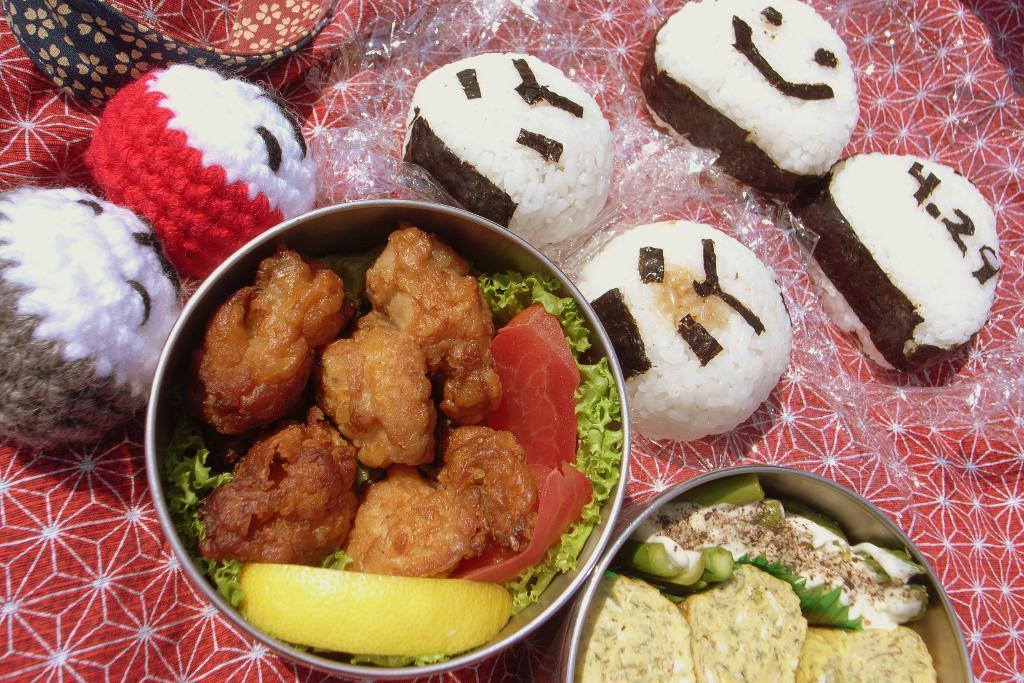What is in the bowls that are visible in the image? There is food in the bowls in the image. What other items can be seen beside the bowls in the image? There are soft toys beside the bowls in the image. What type of tail can be seen on the doctor in the image? There is no doctor present in the image, and therefore no tail can be seen. 